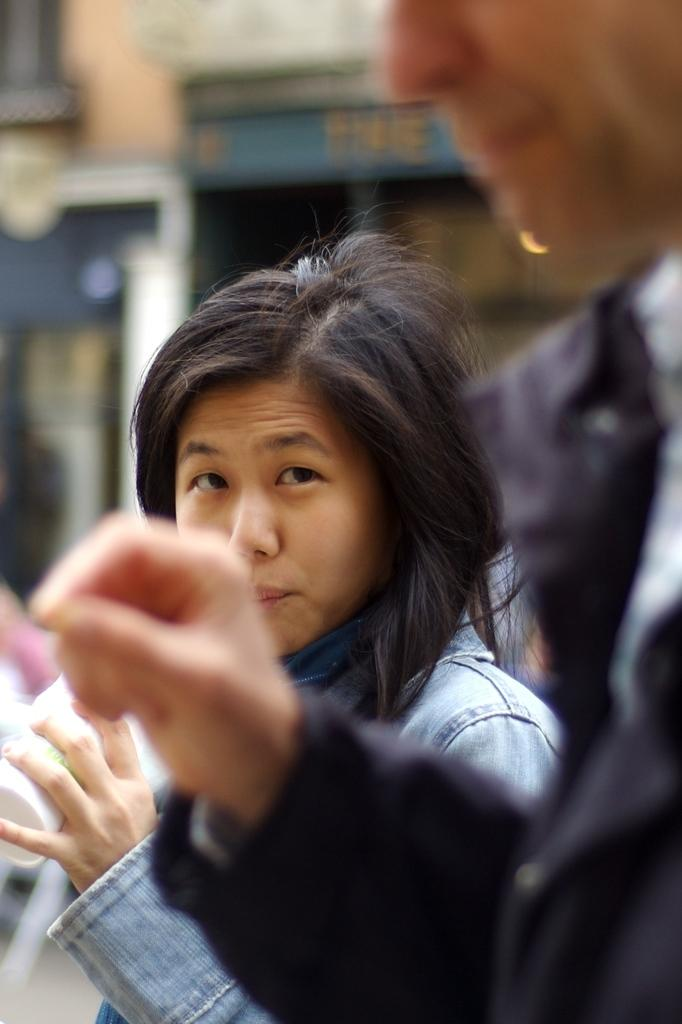Who or what is present in the image? There are people in the image. Can you describe the clothing of the people in the image? The people are wearing different color dresses. What can be observed about the background of the image? The background of the image is blurred. Where is the basin located in the image? There is no basin present in the image. How many additional people are there in the image beyond the first four? The provided facts do not mention a specific number of people, so it is impossible to determine if there is a fifth person in the image. 